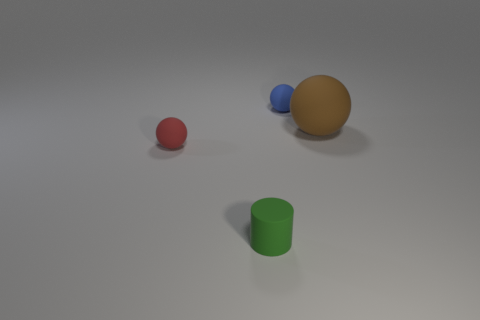Is there anything else that has the same shape as the small green object?
Ensure brevity in your answer.  No. Are there an equal number of large brown matte things that are in front of the red rubber object and big green matte balls?
Offer a very short reply. Yes. What number of red rubber things have the same shape as the large brown thing?
Provide a succinct answer. 1. Is the shape of the brown matte thing the same as the red matte thing?
Offer a terse response. Yes. What number of objects are tiny rubber things that are behind the small green cylinder or small green things?
Make the answer very short. 3. What is the shape of the rubber object that is right of the small thing behind the matte thing right of the blue matte thing?
Make the answer very short. Sphere. There is a green object that is the same material as the tiny red thing; what shape is it?
Your answer should be compact. Cylinder. How big is the green matte thing?
Keep it short and to the point. Small. Does the green cylinder have the same size as the brown thing?
Ensure brevity in your answer.  No. How many objects are balls that are left of the big matte sphere or rubber objects in front of the large brown ball?
Ensure brevity in your answer.  3. 